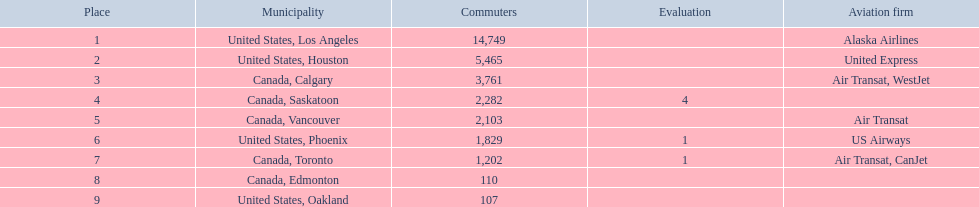Which cities had less than 2,000 passengers? United States, Phoenix, Canada, Toronto, Canada, Edmonton, United States, Oakland. Of these cities, which had fewer than 1,000 passengers? Canada, Edmonton, United States, Oakland. Could you help me parse every detail presented in this table? {'header': ['Place', 'Municipality', 'Commuters', 'Evaluation', 'Aviation firm'], 'rows': [['1', 'United States, Los Angeles', '14,749', '', 'Alaska Airlines'], ['2', 'United States, Houston', '5,465', '', 'United Express'], ['3', 'Canada, Calgary', '3,761', '', 'Air Transat, WestJet'], ['4', 'Canada, Saskatoon', '2,282', '4', ''], ['5', 'Canada, Vancouver', '2,103', '', 'Air Transat'], ['6', 'United States, Phoenix', '1,829', '1', 'US Airways'], ['7', 'Canada, Toronto', '1,202', '1', 'Air Transat, CanJet'], ['8', 'Canada, Edmonton', '110', '', ''], ['9', 'United States, Oakland', '107', '', '']]} Of the cities in the previous answer, which one had only 107 passengers? United States, Oakland. 